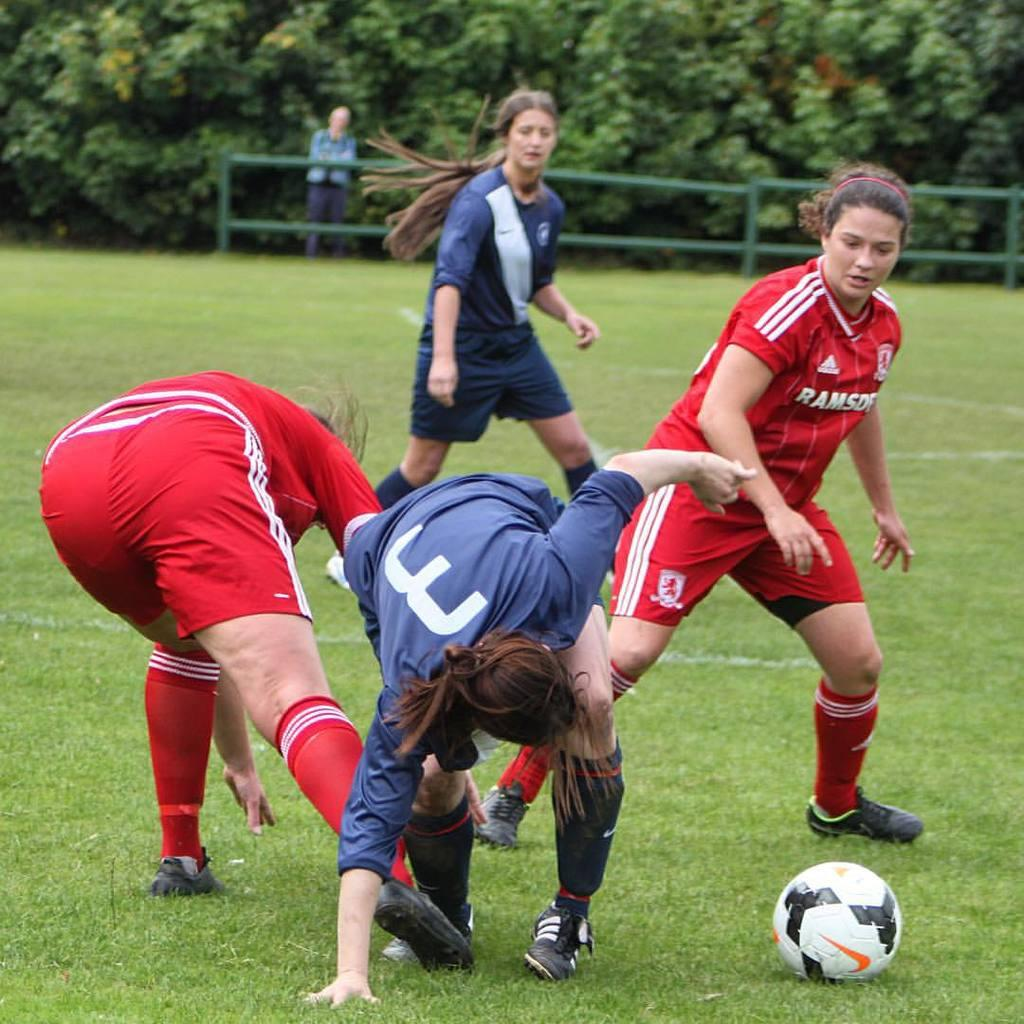<image>
Present a compact description of the photo's key features. females playing soccer, 2 wearing blue and 2 wearing red with letters Ramsd showing on front 